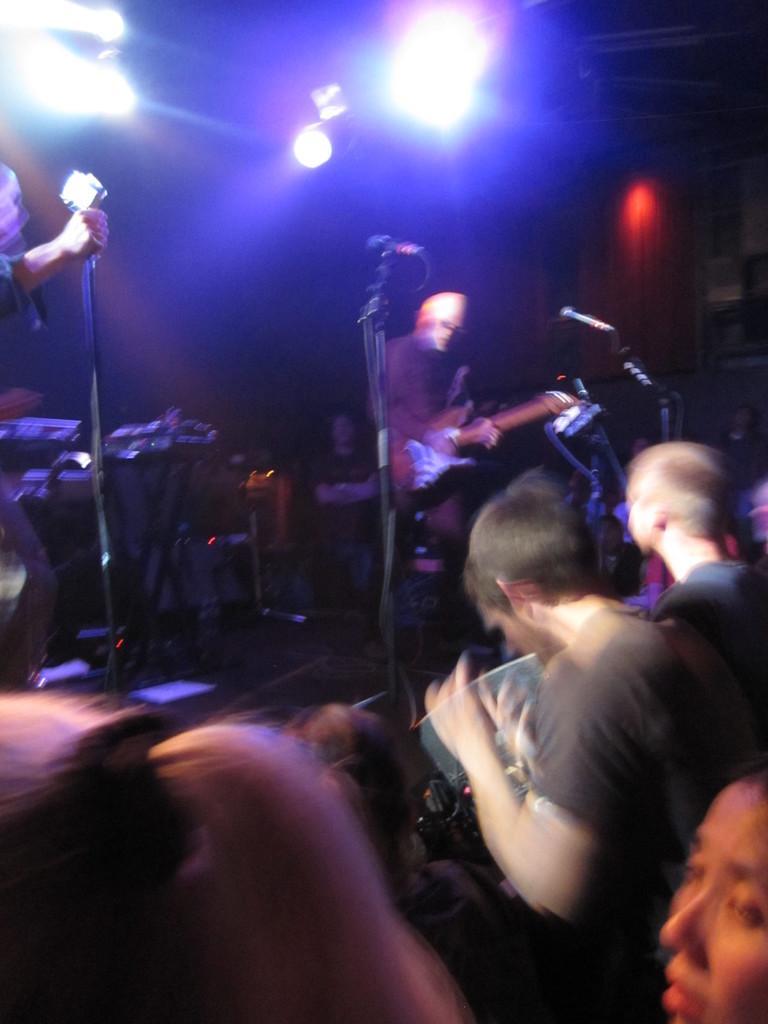Describe this image in one or two sentences. This is the picture of group of People standing at the right side and there is a Person standing in the center and playing Guitar. There is a microphone attached to the stand. There are some Musical instruments at the left side and there is a person standing at the left corner and in the background there are some focusing lights. 